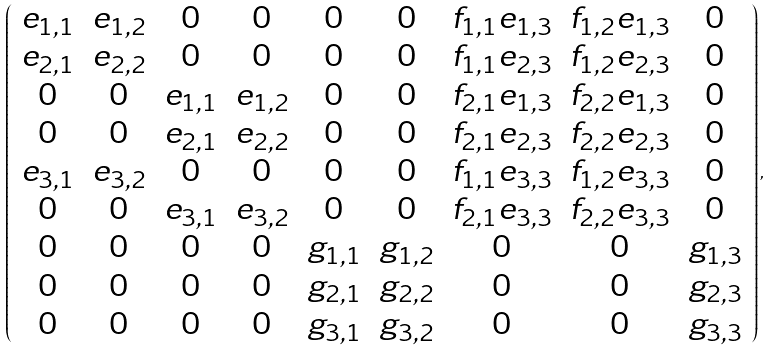Convert formula to latex. <formula><loc_0><loc_0><loc_500><loc_500>\left ( \begin{array} { c c c c c c c c c } e _ { 1 , 1 } & e _ { 1 , 2 } & 0 & 0 & 0 & 0 & f _ { 1 , 1 } e _ { 1 , 3 } & f _ { 1 , 2 } e _ { 1 , 3 } & 0 \\ e _ { 2 , 1 } & e _ { 2 , 2 } & 0 & 0 & 0 & 0 & f _ { 1 , 1 } e _ { 2 , 3 } & f _ { 1 , 2 } e _ { 2 , 3 } & 0 \\ 0 & 0 & e _ { 1 , 1 } & e _ { 1 , 2 } & 0 & 0 & f _ { 2 , 1 } e _ { 1 , 3 } & f _ { 2 , 2 } e _ { 1 , 3 } & 0 \\ 0 & 0 & e _ { 2 , 1 } & e _ { 2 , 2 } & 0 & 0 & f _ { 2 , 1 } e _ { 2 , 3 } & f _ { 2 , 2 } e _ { 2 , 3 } & 0 \\ e _ { 3 , 1 } & e _ { 3 , 2 } & 0 & 0 & 0 & 0 & f _ { 1 , 1 } e _ { 3 , 3 } & f _ { 1 , 2 } e _ { 3 , 3 } & 0 \\ 0 & 0 & e _ { 3 , 1 } & e _ { 3 , 2 } & 0 & 0 & f _ { 2 , 1 } e _ { 3 , 3 } & f _ { 2 , 2 } e _ { 3 , 3 } & 0 \\ 0 & 0 & 0 & 0 & g _ { 1 , 1 } & g _ { 1 , 2 } & 0 & 0 & g _ { 1 , 3 } \\ 0 & 0 & 0 & 0 & g _ { 2 , 1 } & g _ { 2 , 2 } & 0 & 0 & g _ { 2 , 3 } \\ 0 & 0 & 0 & 0 & g _ { 3 , 1 } & g _ { 3 , 2 } & 0 & 0 & g _ { 3 , 3 } \end{array} \right ) ,</formula> 